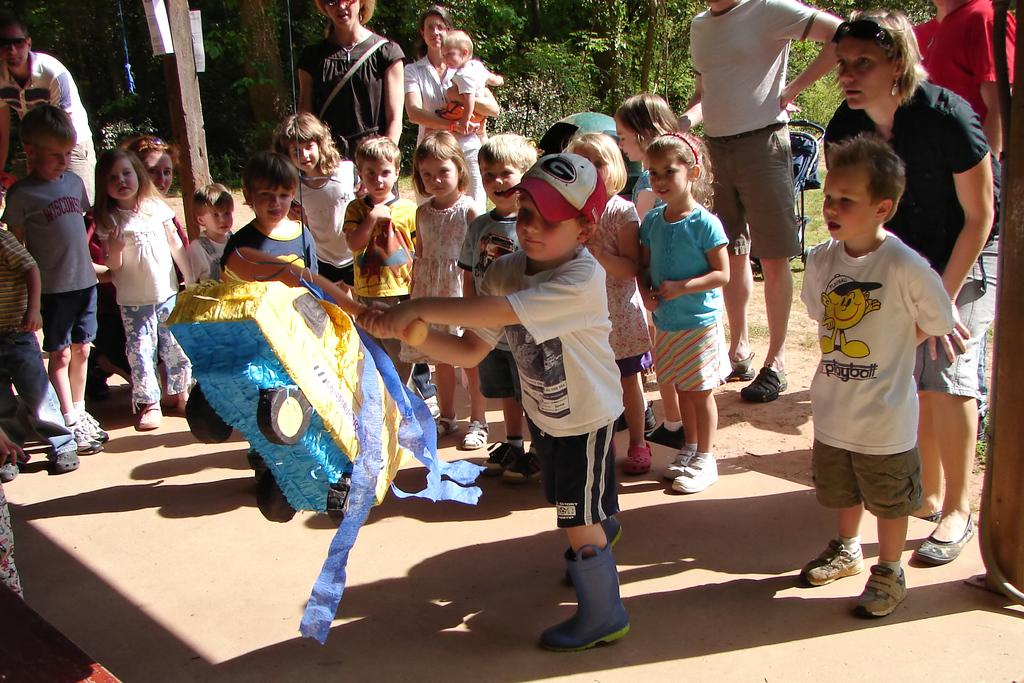What can be seen in the image? There are children in the image, including a kid holding an object near a toy. What is visible in the background of the image? There are trees, people, and a baby chair in the background of the image. What is the woman in the image doing? The woman is carrying a baby in the image. What type of sponge is being used to clean the coal in the image? There is no sponge or coal present in the image. How many buns are visible in the image? There are no buns visible in the image. 